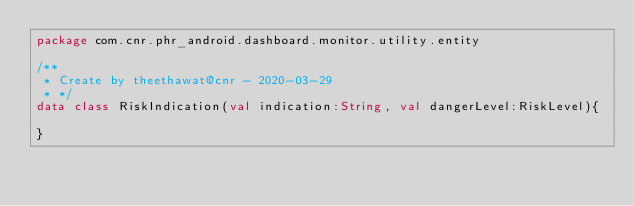Convert code to text. <code><loc_0><loc_0><loc_500><loc_500><_Kotlin_>package com.cnr.phr_android.dashboard.monitor.utility.entity

/**
 * Create by theethawat@cnr - 2020-03-29
 * */
data class RiskIndication(val indication:String, val dangerLevel:RiskLevel){

}</code> 